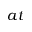<formula> <loc_0><loc_0><loc_500><loc_500>a t</formula> 